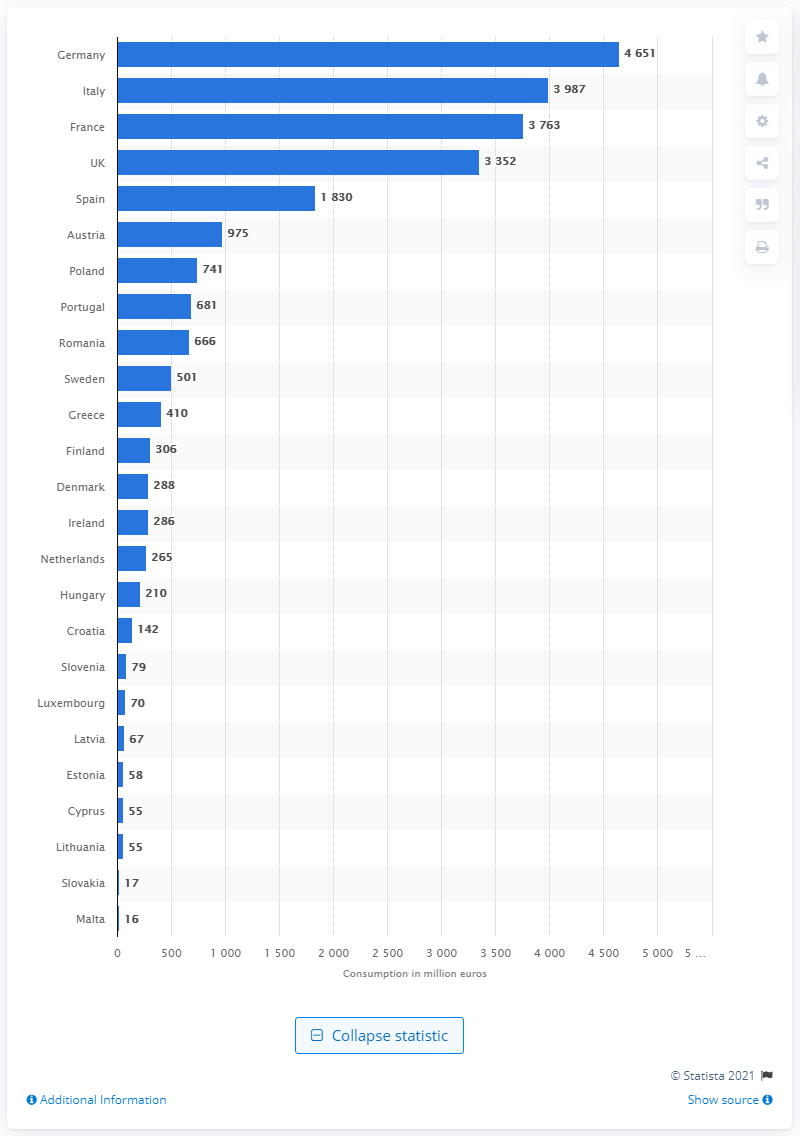Give some essential details in this illustration. According to recent data, Germany has the highest footwear consumption rate among all countries. In 2014, Germany's footwear consumption was 4,651 pairs. 